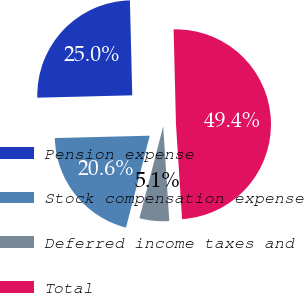Convert chart to OTSL. <chart><loc_0><loc_0><loc_500><loc_500><pie_chart><fcel>Pension expense<fcel>Stock compensation expense<fcel>Deferred income taxes and<fcel>Total<nl><fcel>25.0%<fcel>20.57%<fcel>5.05%<fcel>49.37%<nl></chart> 